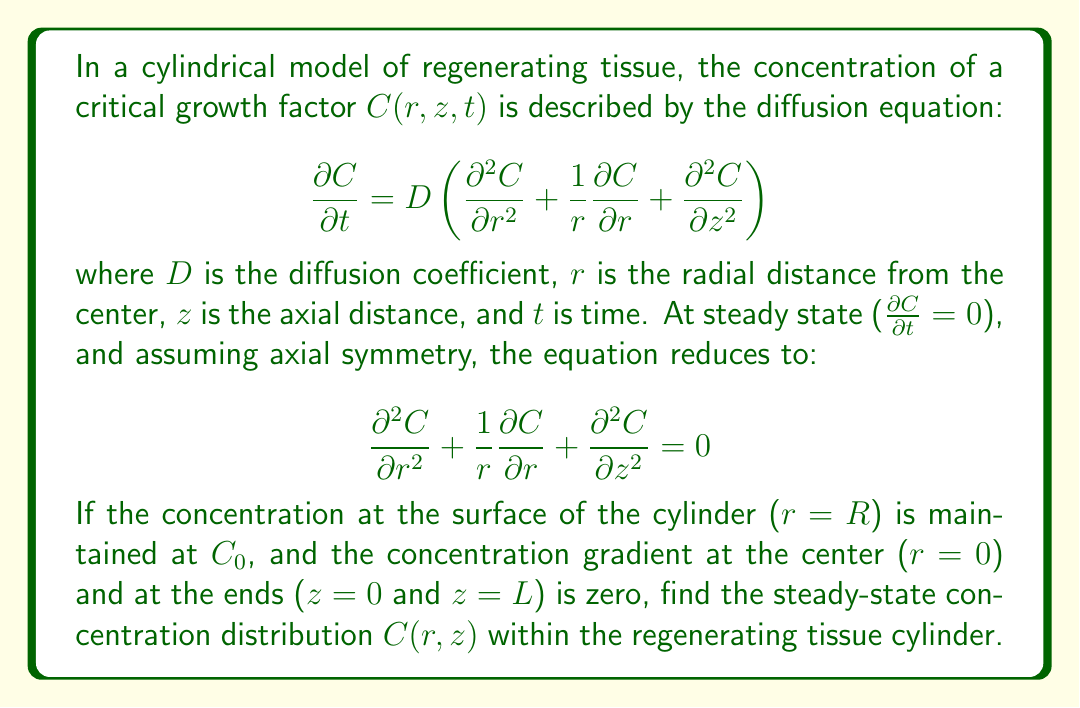What is the answer to this math problem? To solve this problem, we'll use the method of separation of variables and apply the given boundary conditions.

1) Assume the solution has the form $C(r,z) = R(r)Z(z)$.

2) Substituting this into the equation:

   $$\frac{1}{R}\left(\frac{d^2R}{dr^2} + \frac{1}{r}\frac{dR}{dr}\right) = -\frac{1}{Z}\frac{d^2Z}{dz^2} = \lambda^2$$

   where $\lambda^2$ is a separation constant.

3) This gives us two ordinary differential equations:

   For $R(r)$: $\frac{d^2R}{dr^2} + \frac{1}{r}\frac{dR}{dr} - \lambda^2R = 0$
   For $Z(z)$: $\frac{d^2Z}{dz^2} + \lambda^2Z = 0$

4) The general solution for $Z(z)$ is:

   $Z(z) = A\cos(\lambda z) + B\sin(\lambda z)$

5) Applying the boundary conditions at $z = 0$ and $z = L$:

   $\frac{dZ}{dz}|_{z=0} = 0$ implies $B = 0$
   $\frac{dZ}{dz}|_{z=L} = 0$ implies $\lambda = \frac{n\pi}{L}$, where $n = 0, 1, 2, ...$

6) The equation for $R(r)$ is a modified Bessel equation. Its general solution is:

   $R(r) = CI_0(\lambda r) + DK_0(\lambda r)$

   where $I_0$ and $K_0$ are modified Bessel functions of the first and second kind, respectively.

7) Applying the boundary condition at $r = 0$:

   Since $K_0(0)$ is undefined, $D$ must be 0.

8) Applying the boundary condition at $r = R$:

   $R(R) = CI_0(\lambda R) = C_0$

9) The complete solution is thus:

   $$C(r,z) = C_0\sum_{n=0}^{\infty}\frac{I_0(\frac{n\pi r}{L})}{I_0(\frac{n\pi R}{L})}\cos(\frac{n\pi z}{L})$$

10) The $n = 0$ term gives the average concentration $C_0$, and the higher terms represent deviations from this average.
Answer: The steady-state concentration distribution within the regenerating tissue cylinder is given by:

$$C(r,z) = C_0\sum_{n=0}^{\infty}\frac{I_0(\frac{n\pi r}{L})}{I_0(\frac{n\pi R}{L})}\cos(\frac{n\pi z}{L})$$

where $I_0$ is the modified Bessel function of the first kind of order zero, $R$ is the radius of the cylinder, $L$ is the length of the cylinder, and $C_0$ is the concentration at the surface. 